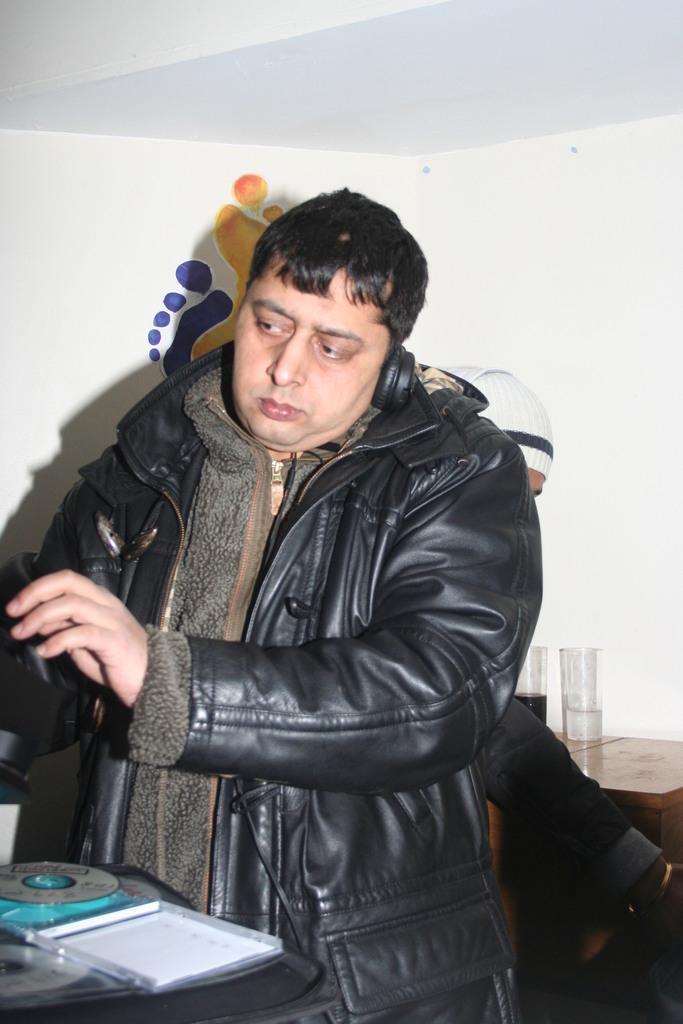How would you summarize this image in a sentence or two? In this picture we can see a man standing in the front, on the left side we can see a disc, in the background there is a wall, we can see a table here, there are two glasses on the table. 